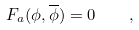<formula> <loc_0><loc_0><loc_500><loc_500>F _ { a } ( \phi , \overline { \phi } ) = 0 \quad ,</formula> 